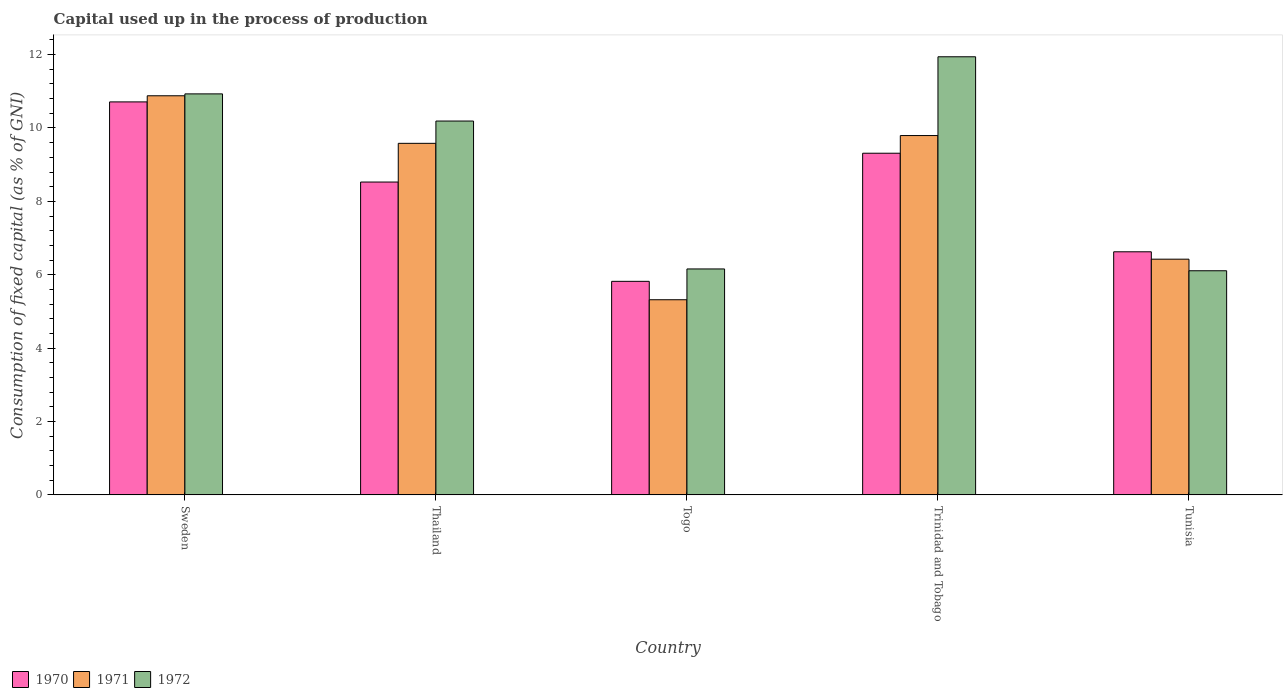Are the number of bars per tick equal to the number of legend labels?
Your answer should be very brief. Yes. How many bars are there on the 3rd tick from the right?
Keep it short and to the point. 3. What is the label of the 3rd group of bars from the left?
Offer a terse response. Togo. What is the capital used up in the process of production in 1972 in Thailand?
Provide a succinct answer. 10.19. Across all countries, what is the maximum capital used up in the process of production in 1970?
Provide a short and direct response. 10.71. Across all countries, what is the minimum capital used up in the process of production in 1972?
Your answer should be very brief. 6.11. In which country was the capital used up in the process of production in 1972 maximum?
Make the answer very short. Trinidad and Tobago. In which country was the capital used up in the process of production in 1970 minimum?
Offer a terse response. Togo. What is the total capital used up in the process of production in 1971 in the graph?
Give a very brief answer. 41.99. What is the difference between the capital used up in the process of production in 1971 in Sweden and that in Thailand?
Give a very brief answer. 1.3. What is the difference between the capital used up in the process of production in 1972 in Thailand and the capital used up in the process of production in 1970 in Sweden?
Offer a terse response. -0.52. What is the average capital used up in the process of production in 1972 per country?
Keep it short and to the point. 9.06. What is the difference between the capital used up in the process of production of/in 1971 and capital used up in the process of production of/in 1970 in Sweden?
Give a very brief answer. 0.17. What is the ratio of the capital used up in the process of production in 1970 in Togo to that in Trinidad and Tobago?
Provide a succinct answer. 0.63. Is the capital used up in the process of production in 1972 in Trinidad and Tobago less than that in Tunisia?
Provide a succinct answer. No. Is the difference between the capital used up in the process of production in 1971 in Trinidad and Tobago and Tunisia greater than the difference between the capital used up in the process of production in 1970 in Trinidad and Tobago and Tunisia?
Provide a short and direct response. Yes. What is the difference between the highest and the second highest capital used up in the process of production in 1971?
Your answer should be compact. -1.08. What is the difference between the highest and the lowest capital used up in the process of production in 1971?
Make the answer very short. 5.56. In how many countries, is the capital used up in the process of production in 1972 greater than the average capital used up in the process of production in 1972 taken over all countries?
Give a very brief answer. 3. Is the sum of the capital used up in the process of production in 1972 in Sweden and Trinidad and Tobago greater than the maximum capital used up in the process of production in 1970 across all countries?
Offer a terse response. Yes. Is it the case that in every country, the sum of the capital used up in the process of production in 1972 and capital used up in the process of production in 1970 is greater than the capital used up in the process of production in 1971?
Your answer should be compact. Yes. How many bars are there?
Ensure brevity in your answer.  15. Are all the bars in the graph horizontal?
Provide a short and direct response. No. How many countries are there in the graph?
Provide a succinct answer. 5. Are the values on the major ticks of Y-axis written in scientific E-notation?
Offer a terse response. No. Does the graph contain any zero values?
Ensure brevity in your answer.  No. Where does the legend appear in the graph?
Provide a succinct answer. Bottom left. What is the title of the graph?
Offer a terse response. Capital used up in the process of production. What is the label or title of the Y-axis?
Give a very brief answer. Consumption of fixed capital (as % of GNI). What is the Consumption of fixed capital (as % of GNI) of 1970 in Sweden?
Make the answer very short. 10.71. What is the Consumption of fixed capital (as % of GNI) in 1971 in Sweden?
Make the answer very short. 10.88. What is the Consumption of fixed capital (as % of GNI) in 1972 in Sweden?
Provide a short and direct response. 10.93. What is the Consumption of fixed capital (as % of GNI) of 1970 in Thailand?
Make the answer very short. 8.53. What is the Consumption of fixed capital (as % of GNI) in 1971 in Thailand?
Your answer should be compact. 9.58. What is the Consumption of fixed capital (as % of GNI) of 1972 in Thailand?
Give a very brief answer. 10.19. What is the Consumption of fixed capital (as % of GNI) of 1970 in Togo?
Provide a succinct answer. 5.82. What is the Consumption of fixed capital (as % of GNI) of 1971 in Togo?
Your answer should be compact. 5.32. What is the Consumption of fixed capital (as % of GNI) of 1972 in Togo?
Provide a short and direct response. 6.16. What is the Consumption of fixed capital (as % of GNI) in 1970 in Trinidad and Tobago?
Your response must be concise. 9.31. What is the Consumption of fixed capital (as % of GNI) of 1971 in Trinidad and Tobago?
Provide a short and direct response. 9.79. What is the Consumption of fixed capital (as % of GNI) in 1972 in Trinidad and Tobago?
Your response must be concise. 11.94. What is the Consumption of fixed capital (as % of GNI) in 1970 in Tunisia?
Ensure brevity in your answer.  6.63. What is the Consumption of fixed capital (as % of GNI) of 1971 in Tunisia?
Your answer should be very brief. 6.42. What is the Consumption of fixed capital (as % of GNI) of 1972 in Tunisia?
Your answer should be very brief. 6.11. Across all countries, what is the maximum Consumption of fixed capital (as % of GNI) in 1970?
Make the answer very short. 10.71. Across all countries, what is the maximum Consumption of fixed capital (as % of GNI) of 1971?
Your answer should be very brief. 10.88. Across all countries, what is the maximum Consumption of fixed capital (as % of GNI) of 1972?
Your response must be concise. 11.94. Across all countries, what is the minimum Consumption of fixed capital (as % of GNI) in 1970?
Make the answer very short. 5.82. Across all countries, what is the minimum Consumption of fixed capital (as % of GNI) in 1971?
Your answer should be very brief. 5.32. Across all countries, what is the minimum Consumption of fixed capital (as % of GNI) of 1972?
Your response must be concise. 6.11. What is the total Consumption of fixed capital (as % of GNI) in 1970 in the graph?
Keep it short and to the point. 40.99. What is the total Consumption of fixed capital (as % of GNI) of 1971 in the graph?
Offer a terse response. 41.99. What is the total Consumption of fixed capital (as % of GNI) of 1972 in the graph?
Provide a succinct answer. 45.33. What is the difference between the Consumption of fixed capital (as % of GNI) in 1970 in Sweden and that in Thailand?
Give a very brief answer. 2.18. What is the difference between the Consumption of fixed capital (as % of GNI) of 1971 in Sweden and that in Thailand?
Your response must be concise. 1.3. What is the difference between the Consumption of fixed capital (as % of GNI) in 1972 in Sweden and that in Thailand?
Offer a terse response. 0.74. What is the difference between the Consumption of fixed capital (as % of GNI) in 1970 in Sweden and that in Togo?
Your response must be concise. 4.89. What is the difference between the Consumption of fixed capital (as % of GNI) of 1971 in Sweden and that in Togo?
Offer a terse response. 5.56. What is the difference between the Consumption of fixed capital (as % of GNI) of 1972 in Sweden and that in Togo?
Your answer should be very brief. 4.77. What is the difference between the Consumption of fixed capital (as % of GNI) in 1970 in Sweden and that in Trinidad and Tobago?
Offer a very short reply. 1.4. What is the difference between the Consumption of fixed capital (as % of GNI) in 1971 in Sweden and that in Trinidad and Tobago?
Keep it short and to the point. 1.08. What is the difference between the Consumption of fixed capital (as % of GNI) in 1972 in Sweden and that in Trinidad and Tobago?
Keep it short and to the point. -1.01. What is the difference between the Consumption of fixed capital (as % of GNI) of 1970 in Sweden and that in Tunisia?
Ensure brevity in your answer.  4.09. What is the difference between the Consumption of fixed capital (as % of GNI) of 1971 in Sweden and that in Tunisia?
Your answer should be compact. 4.45. What is the difference between the Consumption of fixed capital (as % of GNI) in 1972 in Sweden and that in Tunisia?
Your answer should be compact. 4.82. What is the difference between the Consumption of fixed capital (as % of GNI) of 1970 in Thailand and that in Togo?
Your response must be concise. 2.71. What is the difference between the Consumption of fixed capital (as % of GNI) in 1971 in Thailand and that in Togo?
Offer a very short reply. 4.26. What is the difference between the Consumption of fixed capital (as % of GNI) of 1972 in Thailand and that in Togo?
Keep it short and to the point. 4.03. What is the difference between the Consumption of fixed capital (as % of GNI) of 1970 in Thailand and that in Trinidad and Tobago?
Offer a terse response. -0.79. What is the difference between the Consumption of fixed capital (as % of GNI) in 1971 in Thailand and that in Trinidad and Tobago?
Your answer should be very brief. -0.21. What is the difference between the Consumption of fixed capital (as % of GNI) in 1972 in Thailand and that in Trinidad and Tobago?
Your response must be concise. -1.75. What is the difference between the Consumption of fixed capital (as % of GNI) in 1970 in Thailand and that in Tunisia?
Keep it short and to the point. 1.9. What is the difference between the Consumption of fixed capital (as % of GNI) in 1971 in Thailand and that in Tunisia?
Give a very brief answer. 3.16. What is the difference between the Consumption of fixed capital (as % of GNI) of 1972 in Thailand and that in Tunisia?
Your response must be concise. 4.08. What is the difference between the Consumption of fixed capital (as % of GNI) of 1970 in Togo and that in Trinidad and Tobago?
Keep it short and to the point. -3.49. What is the difference between the Consumption of fixed capital (as % of GNI) of 1971 in Togo and that in Trinidad and Tobago?
Offer a very short reply. -4.47. What is the difference between the Consumption of fixed capital (as % of GNI) of 1972 in Togo and that in Trinidad and Tobago?
Keep it short and to the point. -5.78. What is the difference between the Consumption of fixed capital (as % of GNI) of 1970 in Togo and that in Tunisia?
Provide a short and direct response. -0.8. What is the difference between the Consumption of fixed capital (as % of GNI) in 1971 in Togo and that in Tunisia?
Your answer should be very brief. -1.11. What is the difference between the Consumption of fixed capital (as % of GNI) of 1972 in Togo and that in Tunisia?
Your response must be concise. 0.05. What is the difference between the Consumption of fixed capital (as % of GNI) of 1970 in Trinidad and Tobago and that in Tunisia?
Your response must be concise. 2.69. What is the difference between the Consumption of fixed capital (as % of GNI) of 1971 in Trinidad and Tobago and that in Tunisia?
Give a very brief answer. 3.37. What is the difference between the Consumption of fixed capital (as % of GNI) in 1972 in Trinidad and Tobago and that in Tunisia?
Offer a very short reply. 5.83. What is the difference between the Consumption of fixed capital (as % of GNI) of 1970 in Sweden and the Consumption of fixed capital (as % of GNI) of 1971 in Thailand?
Your answer should be very brief. 1.13. What is the difference between the Consumption of fixed capital (as % of GNI) of 1970 in Sweden and the Consumption of fixed capital (as % of GNI) of 1972 in Thailand?
Your answer should be very brief. 0.52. What is the difference between the Consumption of fixed capital (as % of GNI) of 1971 in Sweden and the Consumption of fixed capital (as % of GNI) of 1972 in Thailand?
Make the answer very short. 0.69. What is the difference between the Consumption of fixed capital (as % of GNI) of 1970 in Sweden and the Consumption of fixed capital (as % of GNI) of 1971 in Togo?
Make the answer very short. 5.39. What is the difference between the Consumption of fixed capital (as % of GNI) of 1970 in Sweden and the Consumption of fixed capital (as % of GNI) of 1972 in Togo?
Keep it short and to the point. 4.55. What is the difference between the Consumption of fixed capital (as % of GNI) in 1971 in Sweden and the Consumption of fixed capital (as % of GNI) in 1972 in Togo?
Offer a terse response. 4.72. What is the difference between the Consumption of fixed capital (as % of GNI) of 1970 in Sweden and the Consumption of fixed capital (as % of GNI) of 1971 in Trinidad and Tobago?
Provide a succinct answer. 0.92. What is the difference between the Consumption of fixed capital (as % of GNI) in 1970 in Sweden and the Consumption of fixed capital (as % of GNI) in 1972 in Trinidad and Tobago?
Ensure brevity in your answer.  -1.23. What is the difference between the Consumption of fixed capital (as % of GNI) in 1971 in Sweden and the Consumption of fixed capital (as % of GNI) in 1972 in Trinidad and Tobago?
Keep it short and to the point. -1.06. What is the difference between the Consumption of fixed capital (as % of GNI) of 1970 in Sweden and the Consumption of fixed capital (as % of GNI) of 1971 in Tunisia?
Ensure brevity in your answer.  4.29. What is the difference between the Consumption of fixed capital (as % of GNI) of 1970 in Sweden and the Consumption of fixed capital (as % of GNI) of 1972 in Tunisia?
Your answer should be compact. 4.6. What is the difference between the Consumption of fixed capital (as % of GNI) in 1971 in Sweden and the Consumption of fixed capital (as % of GNI) in 1972 in Tunisia?
Give a very brief answer. 4.77. What is the difference between the Consumption of fixed capital (as % of GNI) of 1970 in Thailand and the Consumption of fixed capital (as % of GNI) of 1971 in Togo?
Your answer should be compact. 3.21. What is the difference between the Consumption of fixed capital (as % of GNI) of 1970 in Thailand and the Consumption of fixed capital (as % of GNI) of 1972 in Togo?
Ensure brevity in your answer.  2.37. What is the difference between the Consumption of fixed capital (as % of GNI) in 1971 in Thailand and the Consumption of fixed capital (as % of GNI) in 1972 in Togo?
Give a very brief answer. 3.42. What is the difference between the Consumption of fixed capital (as % of GNI) in 1970 in Thailand and the Consumption of fixed capital (as % of GNI) in 1971 in Trinidad and Tobago?
Your answer should be very brief. -1.27. What is the difference between the Consumption of fixed capital (as % of GNI) in 1970 in Thailand and the Consumption of fixed capital (as % of GNI) in 1972 in Trinidad and Tobago?
Give a very brief answer. -3.41. What is the difference between the Consumption of fixed capital (as % of GNI) of 1971 in Thailand and the Consumption of fixed capital (as % of GNI) of 1972 in Trinidad and Tobago?
Provide a short and direct response. -2.36. What is the difference between the Consumption of fixed capital (as % of GNI) of 1970 in Thailand and the Consumption of fixed capital (as % of GNI) of 1971 in Tunisia?
Provide a short and direct response. 2.1. What is the difference between the Consumption of fixed capital (as % of GNI) of 1970 in Thailand and the Consumption of fixed capital (as % of GNI) of 1972 in Tunisia?
Your response must be concise. 2.42. What is the difference between the Consumption of fixed capital (as % of GNI) in 1971 in Thailand and the Consumption of fixed capital (as % of GNI) in 1972 in Tunisia?
Keep it short and to the point. 3.47. What is the difference between the Consumption of fixed capital (as % of GNI) in 1970 in Togo and the Consumption of fixed capital (as % of GNI) in 1971 in Trinidad and Tobago?
Your response must be concise. -3.97. What is the difference between the Consumption of fixed capital (as % of GNI) of 1970 in Togo and the Consumption of fixed capital (as % of GNI) of 1972 in Trinidad and Tobago?
Your answer should be very brief. -6.12. What is the difference between the Consumption of fixed capital (as % of GNI) in 1971 in Togo and the Consumption of fixed capital (as % of GNI) in 1972 in Trinidad and Tobago?
Give a very brief answer. -6.62. What is the difference between the Consumption of fixed capital (as % of GNI) of 1970 in Togo and the Consumption of fixed capital (as % of GNI) of 1971 in Tunisia?
Give a very brief answer. -0.6. What is the difference between the Consumption of fixed capital (as % of GNI) of 1970 in Togo and the Consumption of fixed capital (as % of GNI) of 1972 in Tunisia?
Keep it short and to the point. -0.29. What is the difference between the Consumption of fixed capital (as % of GNI) of 1971 in Togo and the Consumption of fixed capital (as % of GNI) of 1972 in Tunisia?
Provide a short and direct response. -0.79. What is the difference between the Consumption of fixed capital (as % of GNI) of 1970 in Trinidad and Tobago and the Consumption of fixed capital (as % of GNI) of 1971 in Tunisia?
Your answer should be very brief. 2.89. What is the difference between the Consumption of fixed capital (as % of GNI) in 1970 in Trinidad and Tobago and the Consumption of fixed capital (as % of GNI) in 1972 in Tunisia?
Your response must be concise. 3.2. What is the difference between the Consumption of fixed capital (as % of GNI) of 1971 in Trinidad and Tobago and the Consumption of fixed capital (as % of GNI) of 1972 in Tunisia?
Keep it short and to the point. 3.68. What is the average Consumption of fixed capital (as % of GNI) of 1970 per country?
Provide a short and direct response. 8.2. What is the average Consumption of fixed capital (as % of GNI) in 1971 per country?
Offer a terse response. 8.4. What is the average Consumption of fixed capital (as % of GNI) of 1972 per country?
Offer a terse response. 9.06. What is the difference between the Consumption of fixed capital (as % of GNI) of 1970 and Consumption of fixed capital (as % of GNI) of 1971 in Sweden?
Your answer should be compact. -0.17. What is the difference between the Consumption of fixed capital (as % of GNI) of 1970 and Consumption of fixed capital (as % of GNI) of 1972 in Sweden?
Ensure brevity in your answer.  -0.22. What is the difference between the Consumption of fixed capital (as % of GNI) of 1971 and Consumption of fixed capital (as % of GNI) of 1972 in Sweden?
Keep it short and to the point. -0.05. What is the difference between the Consumption of fixed capital (as % of GNI) in 1970 and Consumption of fixed capital (as % of GNI) in 1971 in Thailand?
Provide a succinct answer. -1.05. What is the difference between the Consumption of fixed capital (as % of GNI) of 1970 and Consumption of fixed capital (as % of GNI) of 1972 in Thailand?
Offer a terse response. -1.66. What is the difference between the Consumption of fixed capital (as % of GNI) of 1971 and Consumption of fixed capital (as % of GNI) of 1972 in Thailand?
Provide a short and direct response. -0.61. What is the difference between the Consumption of fixed capital (as % of GNI) in 1970 and Consumption of fixed capital (as % of GNI) in 1971 in Togo?
Offer a terse response. 0.5. What is the difference between the Consumption of fixed capital (as % of GNI) of 1970 and Consumption of fixed capital (as % of GNI) of 1972 in Togo?
Your response must be concise. -0.34. What is the difference between the Consumption of fixed capital (as % of GNI) in 1971 and Consumption of fixed capital (as % of GNI) in 1972 in Togo?
Provide a short and direct response. -0.84. What is the difference between the Consumption of fixed capital (as % of GNI) in 1970 and Consumption of fixed capital (as % of GNI) in 1971 in Trinidad and Tobago?
Keep it short and to the point. -0.48. What is the difference between the Consumption of fixed capital (as % of GNI) of 1970 and Consumption of fixed capital (as % of GNI) of 1972 in Trinidad and Tobago?
Ensure brevity in your answer.  -2.63. What is the difference between the Consumption of fixed capital (as % of GNI) of 1971 and Consumption of fixed capital (as % of GNI) of 1972 in Trinidad and Tobago?
Provide a short and direct response. -2.15. What is the difference between the Consumption of fixed capital (as % of GNI) in 1970 and Consumption of fixed capital (as % of GNI) in 1971 in Tunisia?
Keep it short and to the point. 0.2. What is the difference between the Consumption of fixed capital (as % of GNI) of 1970 and Consumption of fixed capital (as % of GNI) of 1972 in Tunisia?
Keep it short and to the point. 0.52. What is the difference between the Consumption of fixed capital (as % of GNI) of 1971 and Consumption of fixed capital (as % of GNI) of 1972 in Tunisia?
Keep it short and to the point. 0.32. What is the ratio of the Consumption of fixed capital (as % of GNI) in 1970 in Sweden to that in Thailand?
Your response must be concise. 1.26. What is the ratio of the Consumption of fixed capital (as % of GNI) in 1971 in Sweden to that in Thailand?
Your response must be concise. 1.14. What is the ratio of the Consumption of fixed capital (as % of GNI) of 1972 in Sweden to that in Thailand?
Your answer should be compact. 1.07. What is the ratio of the Consumption of fixed capital (as % of GNI) of 1970 in Sweden to that in Togo?
Make the answer very short. 1.84. What is the ratio of the Consumption of fixed capital (as % of GNI) in 1971 in Sweden to that in Togo?
Provide a short and direct response. 2.05. What is the ratio of the Consumption of fixed capital (as % of GNI) in 1972 in Sweden to that in Togo?
Provide a succinct answer. 1.77. What is the ratio of the Consumption of fixed capital (as % of GNI) in 1970 in Sweden to that in Trinidad and Tobago?
Provide a succinct answer. 1.15. What is the ratio of the Consumption of fixed capital (as % of GNI) of 1971 in Sweden to that in Trinidad and Tobago?
Make the answer very short. 1.11. What is the ratio of the Consumption of fixed capital (as % of GNI) of 1972 in Sweden to that in Trinidad and Tobago?
Offer a very short reply. 0.92. What is the ratio of the Consumption of fixed capital (as % of GNI) in 1970 in Sweden to that in Tunisia?
Make the answer very short. 1.62. What is the ratio of the Consumption of fixed capital (as % of GNI) in 1971 in Sweden to that in Tunisia?
Provide a short and direct response. 1.69. What is the ratio of the Consumption of fixed capital (as % of GNI) in 1972 in Sweden to that in Tunisia?
Your answer should be compact. 1.79. What is the ratio of the Consumption of fixed capital (as % of GNI) in 1970 in Thailand to that in Togo?
Offer a very short reply. 1.47. What is the ratio of the Consumption of fixed capital (as % of GNI) of 1971 in Thailand to that in Togo?
Make the answer very short. 1.8. What is the ratio of the Consumption of fixed capital (as % of GNI) in 1972 in Thailand to that in Togo?
Keep it short and to the point. 1.65. What is the ratio of the Consumption of fixed capital (as % of GNI) in 1970 in Thailand to that in Trinidad and Tobago?
Your response must be concise. 0.92. What is the ratio of the Consumption of fixed capital (as % of GNI) in 1971 in Thailand to that in Trinidad and Tobago?
Your answer should be very brief. 0.98. What is the ratio of the Consumption of fixed capital (as % of GNI) of 1972 in Thailand to that in Trinidad and Tobago?
Your answer should be very brief. 0.85. What is the ratio of the Consumption of fixed capital (as % of GNI) in 1970 in Thailand to that in Tunisia?
Offer a very short reply. 1.29. What is the ratio of the Consumption of fixed capital (as % of GNI) of 1971 in Thailand to that in Tunisia?
Provide a short and direct response. 1.49. What is the ratio of the Consumption of fixed capital (as % of GNI) of 1972 in Thailand to that in Tunisia?
Provide a succinct answer. 1.67. What is the ratio of the Consumption of fixed capital (as % of GNI) in 1970 in Togo to that in Trinidad and Tobago?
Your response must be concise. 0.63. What is the ratio of the Consumption of fixed capital (as % of GNI) of 1971 in Togo to that in Trinidad and Tobago?
Make the answer very short. 0.54. What is the ratio of the Consumption of fixed capital (as % of GNI) in 1972 in Togo to that in Trinidad and Tobago?
Keep it short and to the point. 0.52. What is the ratio of the Consumption of fixed capital (as % of GNI) in 1970 in Togo to that in Tunisia?
Offer a very short reply. 0.88. What is the ratio of the Consumption of fixed capital (as % of GNI) of 1971 in Togo to that in Tunisia?
Offer a terse response. 0.83. What is the ratio of the Consumption of fixed capital (as % of GNI) of 1970 in Trinidad and Tobago to that in Tunisia?
Offer a terse response. 1.41. What is the ratio of the Consumption of fixed capital (as % of GNI) of 1971 in Trinidad and Tobago to that in Tunisia?
Offer a terse response. 1.52. What is the ratio of the Consumption of fixed capital (as % of GNI) in 1972 in Trinidad and Tobago to that in Tunisia?
Give a very brief answer. 1.95. What is the difference between the highest and the second highest Consumption of fixed capital (as % of GNI) in 1970?
Make the answer very short. 1.4. What is the difference between the highest and the second highest Consumption of fixed capital (as % of GNI) of 1971?
Provide a succinct answer. 1.08. What is the difference between the highest and the second highest Consumption of fixed capital (as % of GNI) in 1972?
Provide a short and direct response. 1.01. What is the difference between the highest and the lowest Consumption of fixed capital (as % of GNI) of 1970?
Offer a terse response. 4.89. What is the difference between the highest and the lowest Consumption of fixed capital (as % of GNI) of 1971?
Keep it short and to the point. 5.56. What is the difference between the highest and the lowest Consumption of fixed capital (as % of GNI) in 1972?
Offer a very short reply. 5.83. 